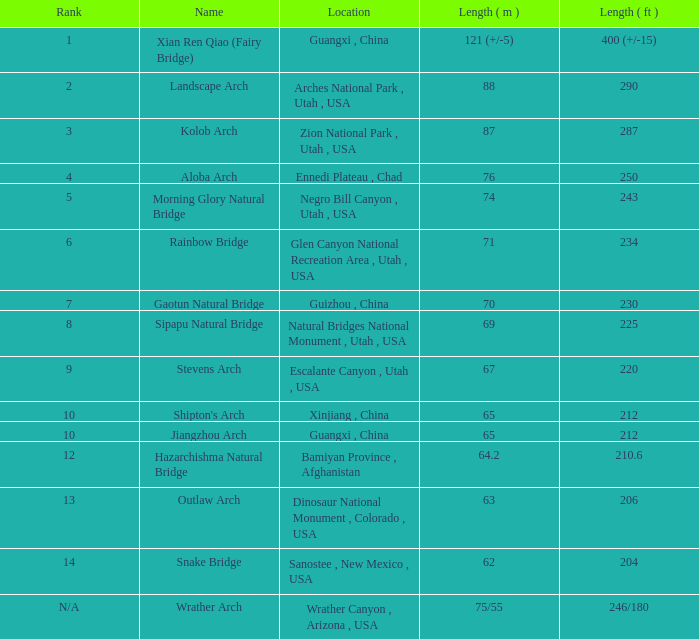What is the length in feet when the length in meters is 64.2? 210.6. 